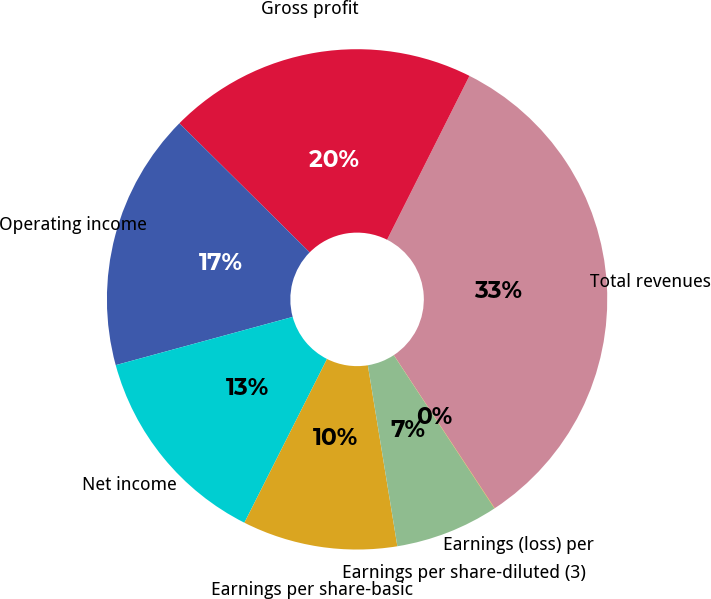Convert chart. <chart><loc_0><loc_0><loc_500><loc_500><pie_chart><fcel>Total revenues<fcel>Gross profit<fcel>Operating income<fcel>Net income<fcel>Earnings per share-basic<fcel>Earnings per share-diluted (3)<fcel>Earnings (loss) per<nl><fcel>33.31%<fcel>19.99%<fcel>16.66%<fcel>13.33%<fcel>10.01%<fcel>6.68%<fcel>0.02%<nl></chart> 